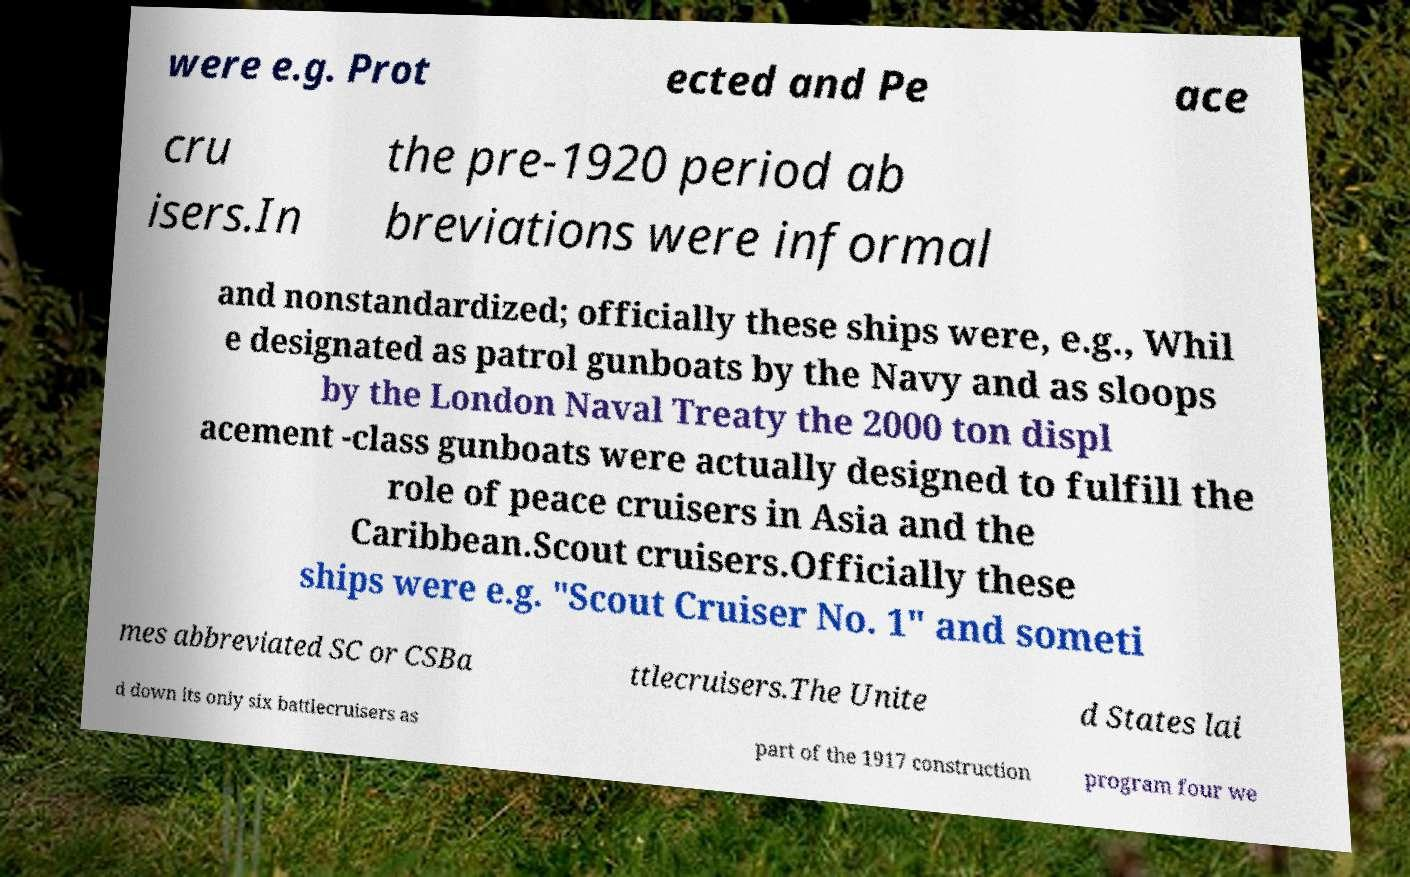Could you assist in decoding the text presented in this image and type it out clearly? were e.g. Prot ected and Pe ace cru isers.In the pre-1920 period ab breviations were informal and nonstandardized; officially these ships were, e.g., Whil e designated as patrol gunboats by the Navy and as sloops by the London Naval Treaty the 2000 ton displ acement -class gunboats were actually designed to fulfill the role of peace cruisers in Asia and the Caribbean.Scout cruisers.Officially these ships were e.g. "Scout Cruiser No. 1" and someti mes abbreviated SC or CSBa ttlecruisers.The Unite d States lai d down its only six battlecruisers as part of the 1917 construction program four we 